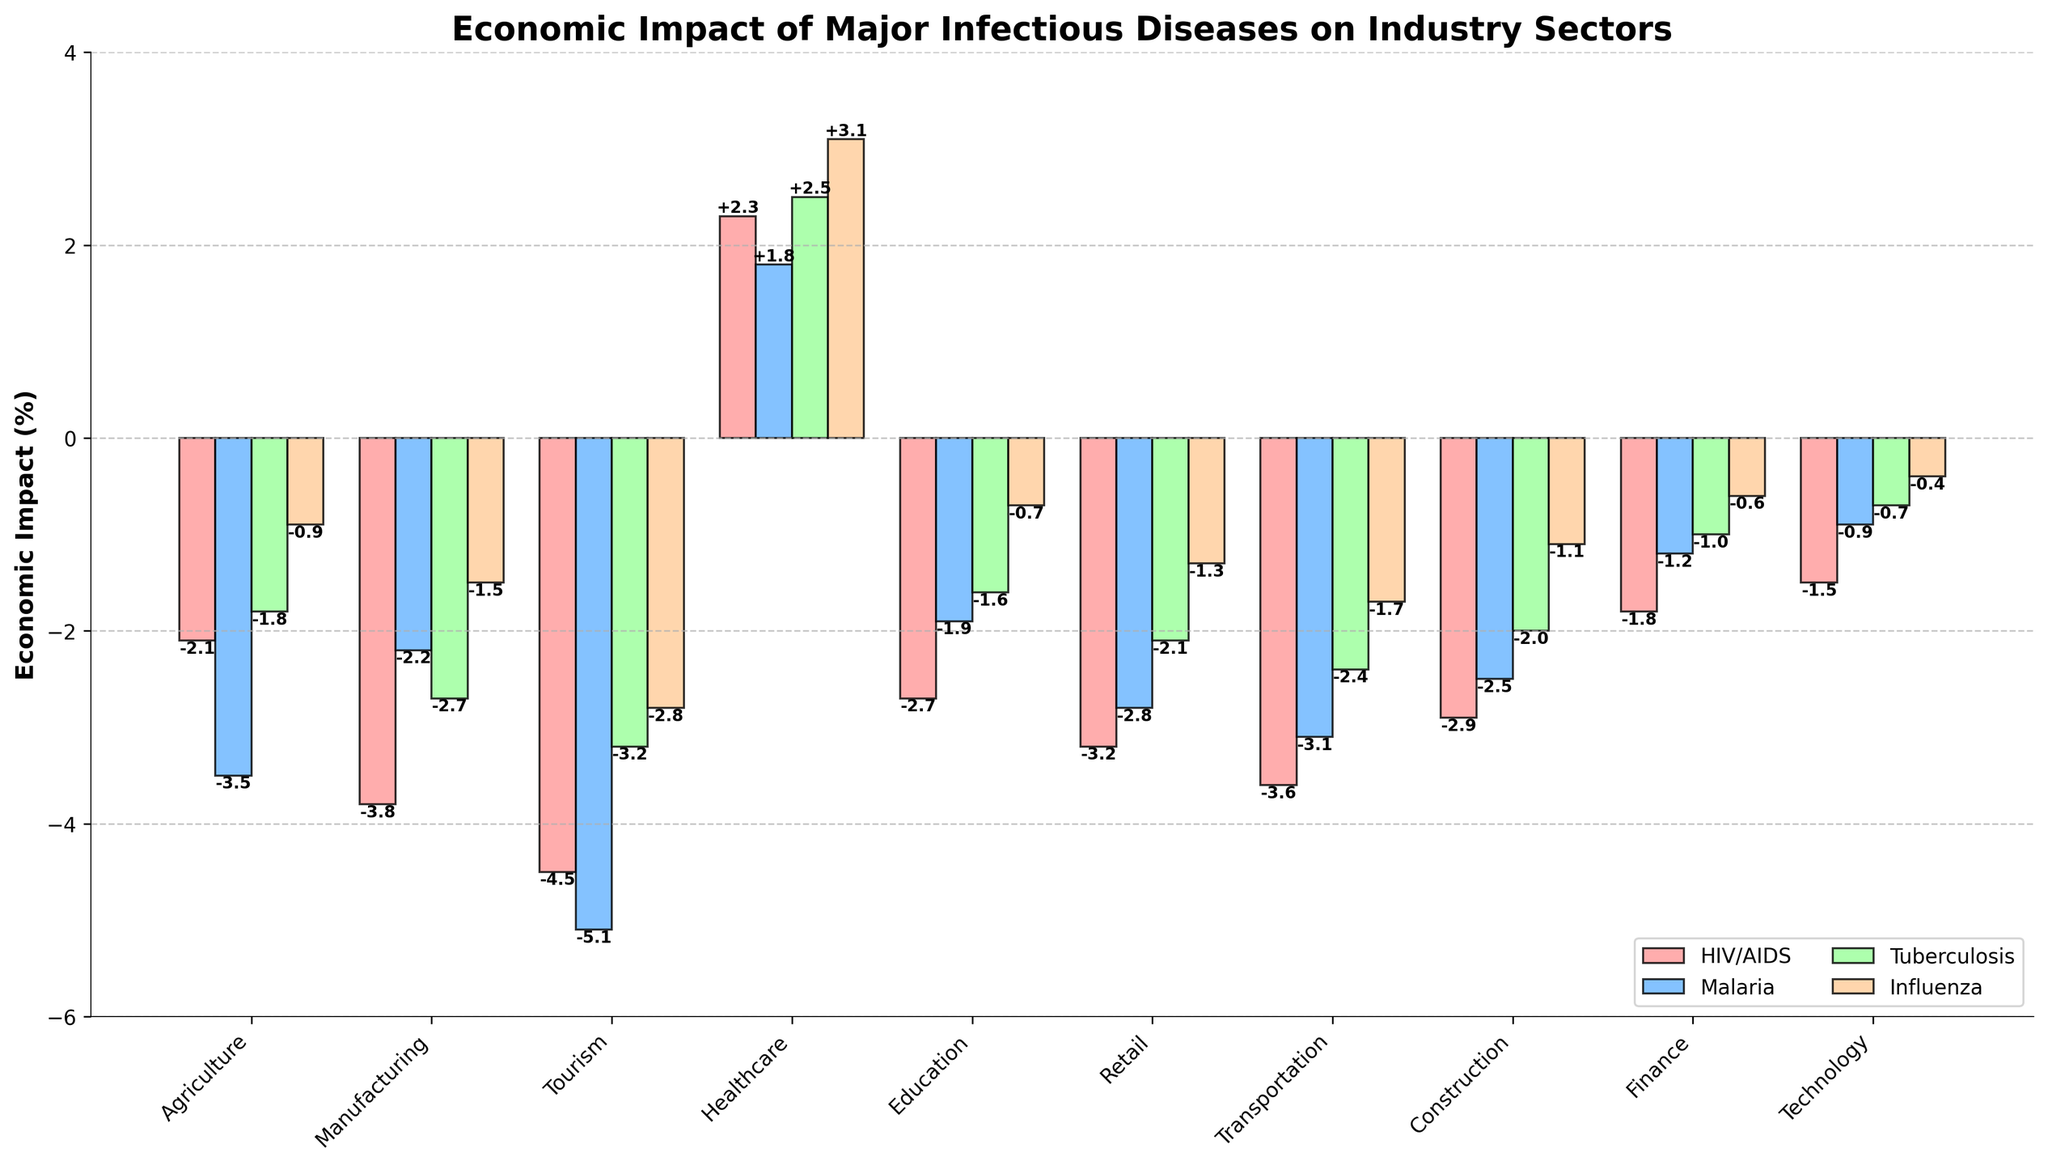Which industry sector experiences the highest negative economic impact due to Malaria? To determine which industry sector experiences the highest negative economic impact due to Malaria, view and compare the heights of the bars colored blue (representing Malaria) in the bar chart. The highest negative impact is shown by the longest bar extending downward. The tourism sector, with a -5.1% impact, has the longest blue bar.
Answer: Tourism Compare the economic impact of HIV/AIDS on the Agriculture sector with the impact of Influenza on the same sector. Which is more severe? To compare the economic impact of HIV/AIDS on the Agriculture sector with Influenza, locate the red bar for HIV/AIDS and the orange bar for Influenza both in the Agriculture sector. The red bar extends to -2.1%, while the orange bar extends to -0.9%. Thus, HIV/AIDS has a more severe economic impact on Agriculture.
Answer: HIV/AIDS Which disease has a positive economic impact on the Healthcare sector? Explain by referencing the bar colors. To find the disease with a positive economic impact on the Healthcare sector, observe the bars for the Healthcare category. All bars are upward (positive). The positive bars in red, blue, green, and orange represent HIV/AIDS (+2.3%), Malaria (+1.8%), Tuberculosis (+2.5%), and Influenza (+3.1%) respectively.
Answer: HIV/AIDS, Malaria, Tuberculosis, Influenza Calculate the average economic impact of Tuberculosis across all industry sectors. To calculate the average economic impact of Tuberculosis, sum the values of economic impacts for all sectors from the green bars, then divide by the number of sectors: (-1.8) + (-2.7) + (-3.2) + (2.5) + (-1.6) + (-2.1) + (-2.4) + (-2.0) + (-1.0) + (-0.7) = -13.0. There are 10 sectors, so the average impact is -13.0 / 10 = -1.3
Answer: -1.3 Compare the total negative impact of HIV/AIDS and Tuberculosis on the Manufacturing sector. To compare, observe the heights of the red and green bars for HIV/AIDS (-3.8) and Tuberculosis (-2.7) in Manufacturing. Both impacts are negative, and HIV/AIDS (-3.8) is more severe than Tuberculosis (-2.7). The difference is -3.8 - (-2.7) = -1.1.
Answer: HIV/AIDS Which sectors experience a greater economic impact from Malaria compared to HIV/AIDS? To identify sectors with a greater impact from Malaria than HIV/AIDS, compare the blue and red bars in each category. Sectors where the blue bar is longer (more negative) include Agriculture, Tourism, Education, Retail, Transportation, and Construction.
Answer: Agriculture, Tourism, Education, Retail, Transportation, Construction 